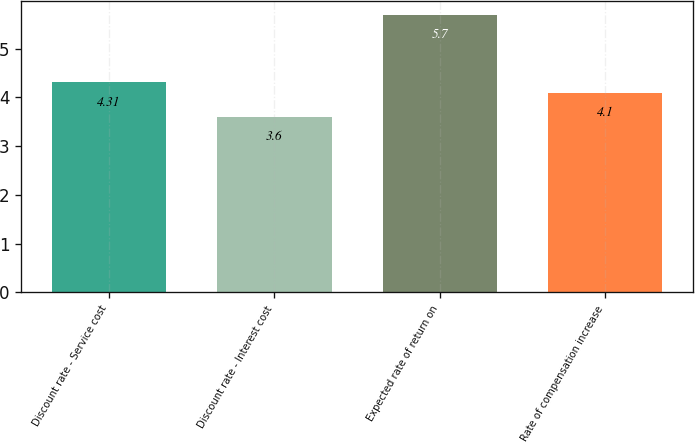Convert chart to OTSL. <chart><loc_0><loc_0><loc_500><loc_500><bar_chart><fcel>Discount rate - Service cost<fcel>Discount rate - Interest cost<fcel>Expected rate of return on<fcel>Rate of compensation increase<nl><fcel>4.31<fcel>3.6<fcel>5.7<fcel>4.1<nl></chart> 